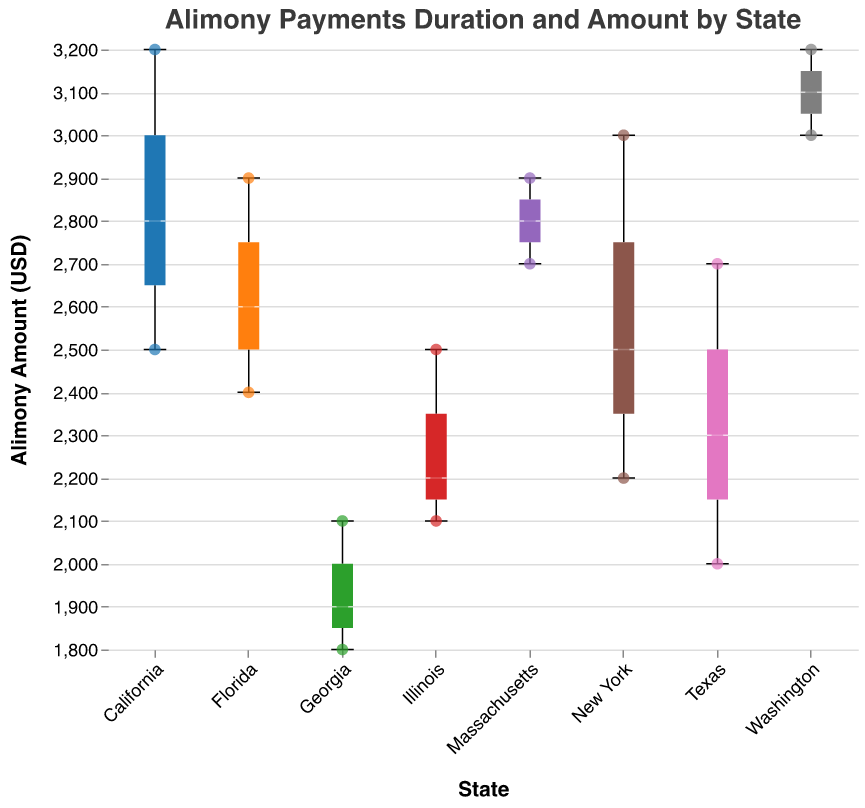How many states are represented in the figure? There are different colored elements for each state in the plot. Counting these unique colors or the state names on the x-axis can give us the number of states.
Answer: 7 What is the highest median alimony amount among all states? The median is represented by the line within each box in the box plot. By comparing the heights of these median lines across all states, the highest can be found adjacent to Washington.
Answer: 3100 USD Which state has the largest interquartile range (IQR) for alimony amounts? The IQR is represented by the height of the box itself, which contains 50% of the data points. By examining all the box heights visually, Massachusetts has the largest IQR.
Answer: Massachusetts What is the median alimony amount for New York? The line within the box plot for New York represents the median alimony amount.
Answer: 2500 USD How does the median alimony amount in Texas compare to that in Florida? Compare the horizontal lines within the box plots for Texas and Florida. Texas has a lower median than Florida.
Answer: Texas has a lower median than Florida Which state(s) has/have the widest range (min-max) in alimony amounts? The range is represented by the distance between the top and bottom "whiskers" of each box plot. Comparing these visually, California has the widest range.
Answer: California Are there any outliers in the alimony data, and if so, which states have them? Outliers are typically represented by individual points outside the whiskers of the box plot. In this case, there are no outliers shown, as all points fall within the whiskers.
Answer: No outliers What is the minimum alimony amount observed in Georgia? The minimum value is represented by the bottom whisker of the box plot for Georgia.
Answer: 1800 USD Comparing California and Washington, which state shows greater variability in alimony amounts? Greater variability can be judged by comparing the spread between the minimum and maximum values (whiskers) and the overall box height. California shows greater variability.
Answer: California Based on the figure, which state seems to have the shortest typical duration of alimony payments (median value)? The median duration is indicated by the line inside each box plot. By looking at the tooltip data for durations and comparing medians across states, Georgia has the shortest typical duration.
Answer: Georgia 